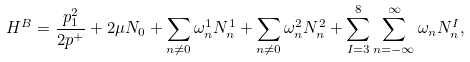<formula> <loc_0><loc_0><loc_500><loc_500>H ^ { B } = \frac { p _ { 1 } ^ { 2 } } { 2 p ^ { + } } + 2 \mu N _ { 0 } + \sum _ { n \neq 0 } \omega ^ { 1 } _ { n } N ^ { 1 } _ { n } + \sum _ { n \neq 0 } \omega ^ { 2 } _ { n } N ^ { 2 } _ { n } + \sum _ { I = 3 } ^ { 8 } \sum _ { n = - \infty } ^ { \infty } \omega _ { n } N _ { n } ^ { I } ,</formula> 